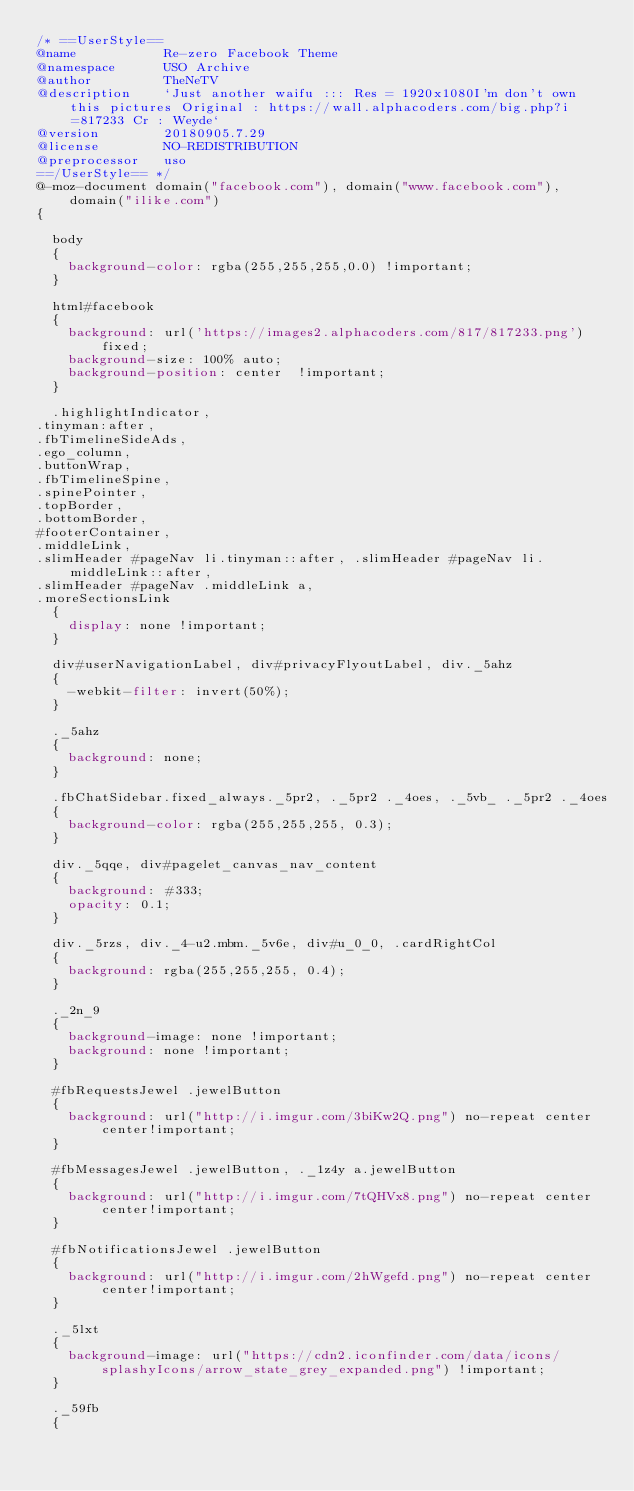<code> <loc_0><loc_0><loc_500><loc_500><_CSS_>/* ==UserStyle==
@name           Re-zero Facebook Theme
@namespace      USO Archive
@author         TheNeTV
@description    `Just another waifu ::: Res = 1920x1080I'm don't own this pictures Original : https://wall.alphacoders.com/big.php?i=817233 Cr : Weyde`
@version        20180905.7.29
@license        NO-REDISTRIBUTION
@preprocessor   uso
==/UserStyle== */
@-moz-document domain("facebook.com"), domain("www.facebook.com"), domain("ilike.com")
{

  body
  {
    background-color: rgba(255,255,255,0.0) !important;
  }

  html#facebook
  {
    background: url('https://images2.alphacoders.com/817/817233.png') fixed;
    background-size: 100% auto;
    background-position: center  !important;
  }

  .highlightIndicator, 
.tinyman:after, 
.fbTimelineSideAds,
.ego_column,
.buttonWrap, 
.fbTimelineSpine, 
.spinePointer, 
.topBorder, 
.bottomBorder, 
#footerContainer, 
.middleLink, 
.slimHeader #pageNav li.tinyman::after, .slimHeader #pageNav li.middleLink::after, 
.slimHeader #pageNav .middleLink a, 
.moreSectionsLink
  {
    display: none !important;
  }

  div#userNavigationLabel, div#privacyFlyoutLabel, div._5ahz
  {
    -webkit-filter: invert(50%);
  }

  ._5ahz
  {
    background: none;
  }

  .fbChatSidebar.fixed_always._5pr2, ._5pr2 ._4oes, ._5vb_ ._5pr2 ._4oes
  {
    background-color: rgba(255,255,255, 0.3);
  }

  div._5qqe, div#pagelet_canvas_nav_content
  {
    background: #333;
    opacity: 0.1;
  }

  div._5rzs, div._4-u2.mbm._5v6e, div#u_0_0, .cardRightCol
  {
    background: rgba(255,255,255, 0.4);
  }

  ._2n_9
  {
    background-image: none !important;
    background: none !important;
  }

  #fbRequestsJewel .jewelButton
  {
    background: url("http://i.imgur.com/3biKw2Q.png") no-repeat center center!important;
  }

  #fbMessagesJewel .jewelButton, ._1z4y a.jewelButton
  {
    background: url("http://i.imgur.com/7tQHVx8.png") no-repeat center center!important;
  }

  #fbNotificationsJewel .jewelButton
  {
    background: url("http://i.imgur.com/2hWgefd.png") no-repeat center center!important;
  }

  ._5lxt
  {
    background-image: url("https://cdn2.iconfinder.com/data/icons/splashyIcons/arrow_state_grey_expanded.png") !important;
  }

  ._59fb
  {</code> 